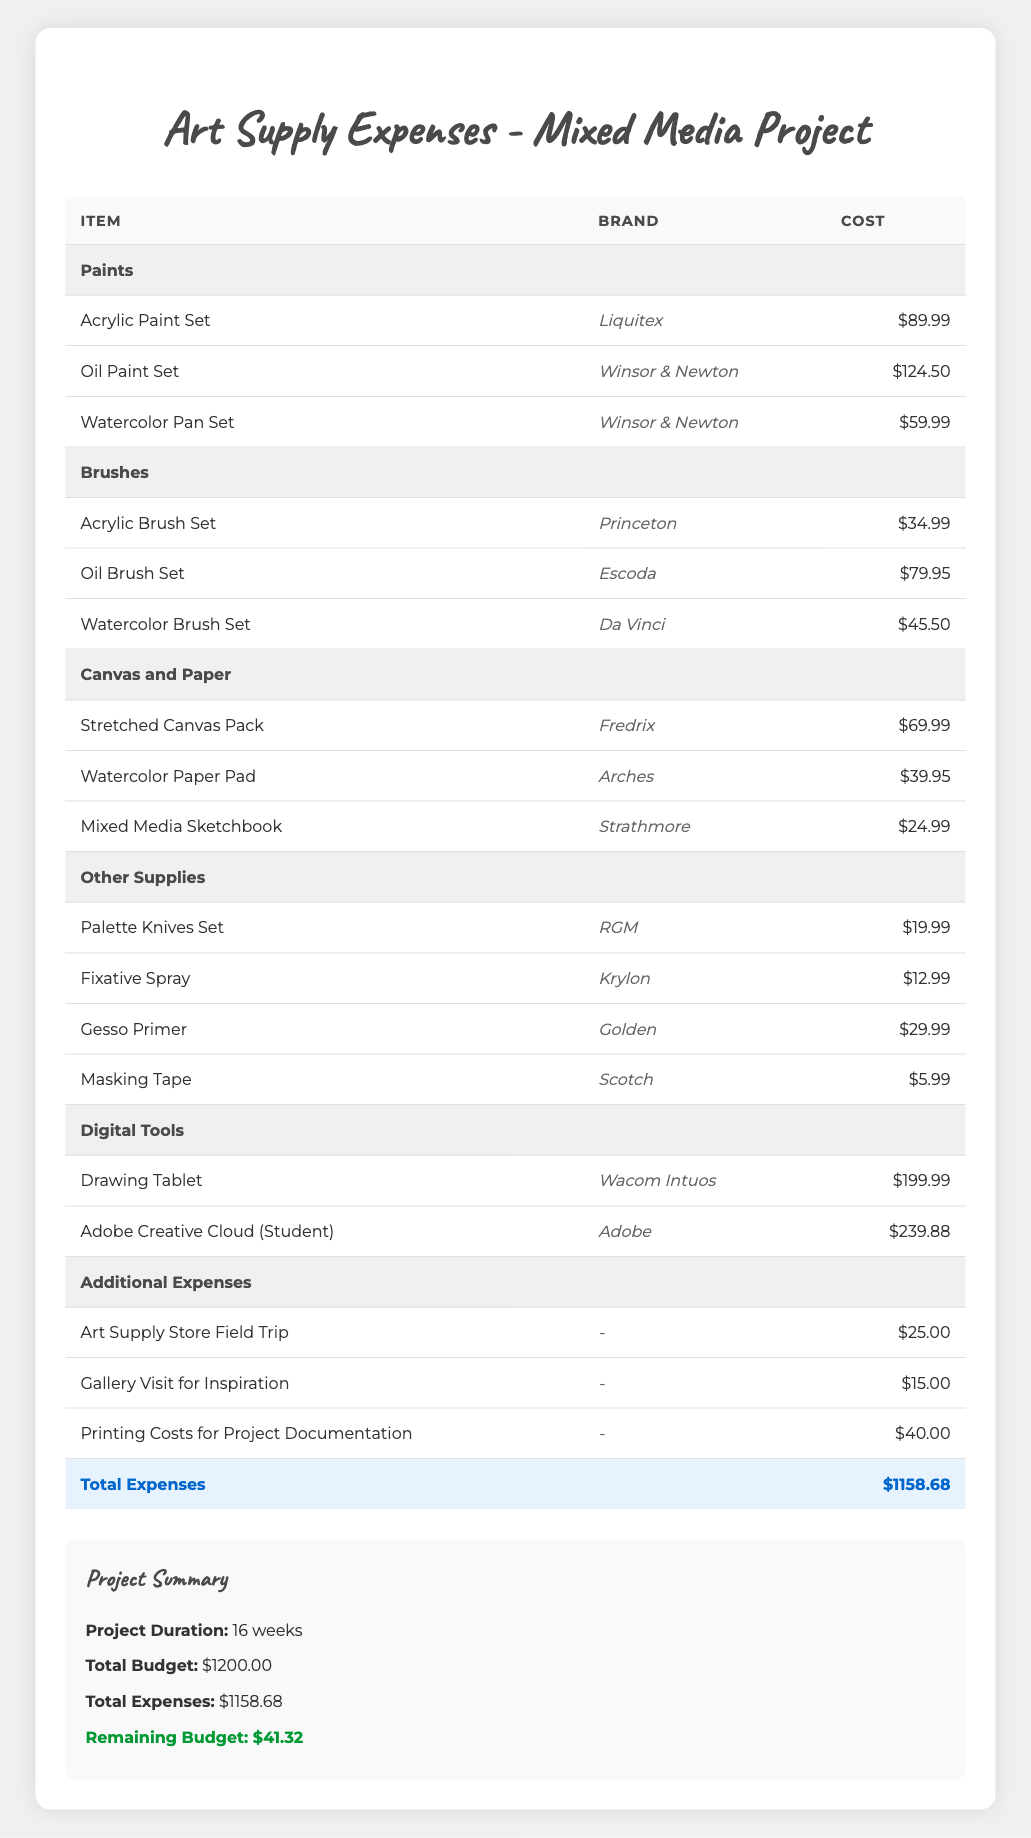What is the cost of the Oil Paint Set? The Oil Paint Set is listed in the Paints category under items, and its cost is directly provided in the table as $124.50.
Answer: $124.50 How much does the total of the Additional Expenses amount to? The Additional Expenses include three line items: $25.00 for the Art Supply Store Field Trip, $15.00 for the Gallery Visit for Inspiration, and $40.00 for Printing Costs for Project Documentation. Adding these amounts gives $25.00 + $15.00 + $40.00 = $80.00.
Answer: $80.00 Is the total expenses greater than the total budget? The Total Expenses amount to $1158.68, while the Total Budget is $1200.00. Since $1158.68 is less than $1200.00, the statement is false.
Answer: No What is the combined cost of all the Brush sets? The cost of the Brush sets are: Acrylic Brush Set $34.99, Oil Brush Set $79.95, and Watercolor Brush Set $45.50. Adding these, we have $34.99 + $79.95 + $45.50 = $160.44.
Answer: $160.44 How many different items are listed under the category of Canvas and Paper? In this category, three items are listed: Stretched Canvas Pack, Watercolor Paper Pad, and Mixed Media Sketchbook. Counting these gives a total of 3 items.
Answer: 3 What is the average cost of all the Paint sets? The Paint sets are $89.99 (Acrylic), $124.50 (Oil), and $59.99 (Watercolor). To find the average, sum the costs: $89.99 + $124.50 + $59.99 = $274.48. There are 3 Paint sets, so the average is $274.48 / 3 = $91.49.
Answer: $91.49 What is the difference between the total budget and the total expenses? The Total Budget is $1200.00 and the Total Expenses are $1158.68. To find the difference, subtract the Total Expenses from the Total Budget: $1200.00 - $1158.68 = $41.32.
Answer: $41.32 Are there any supplies costing less than $10? Looking through all the listed supplies, the lowest cost item is the Masking Tape at $5.99. Since there is an item below $10, the answer is true.
Answer: Yes 